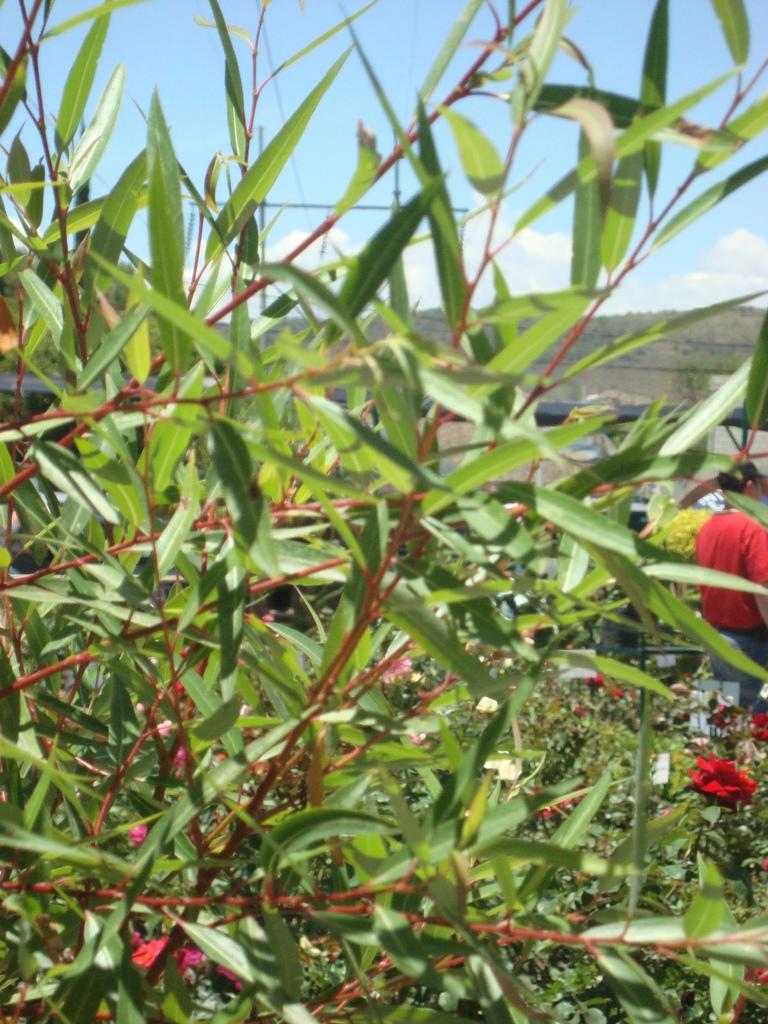What type of plants are featured in the image? There is a group of plants with flowers in the image. Can you describe the person in the image? There is a person standing on the backside of the image. What can be seen in the distance in the image? Hills are visible in the background of the image. What is the condition of the sky in the image? The sky appears to be cloudy in the image. What type of twist is the person performing in the image? There is no twist being performed by the person in the image; they are simply standing. 